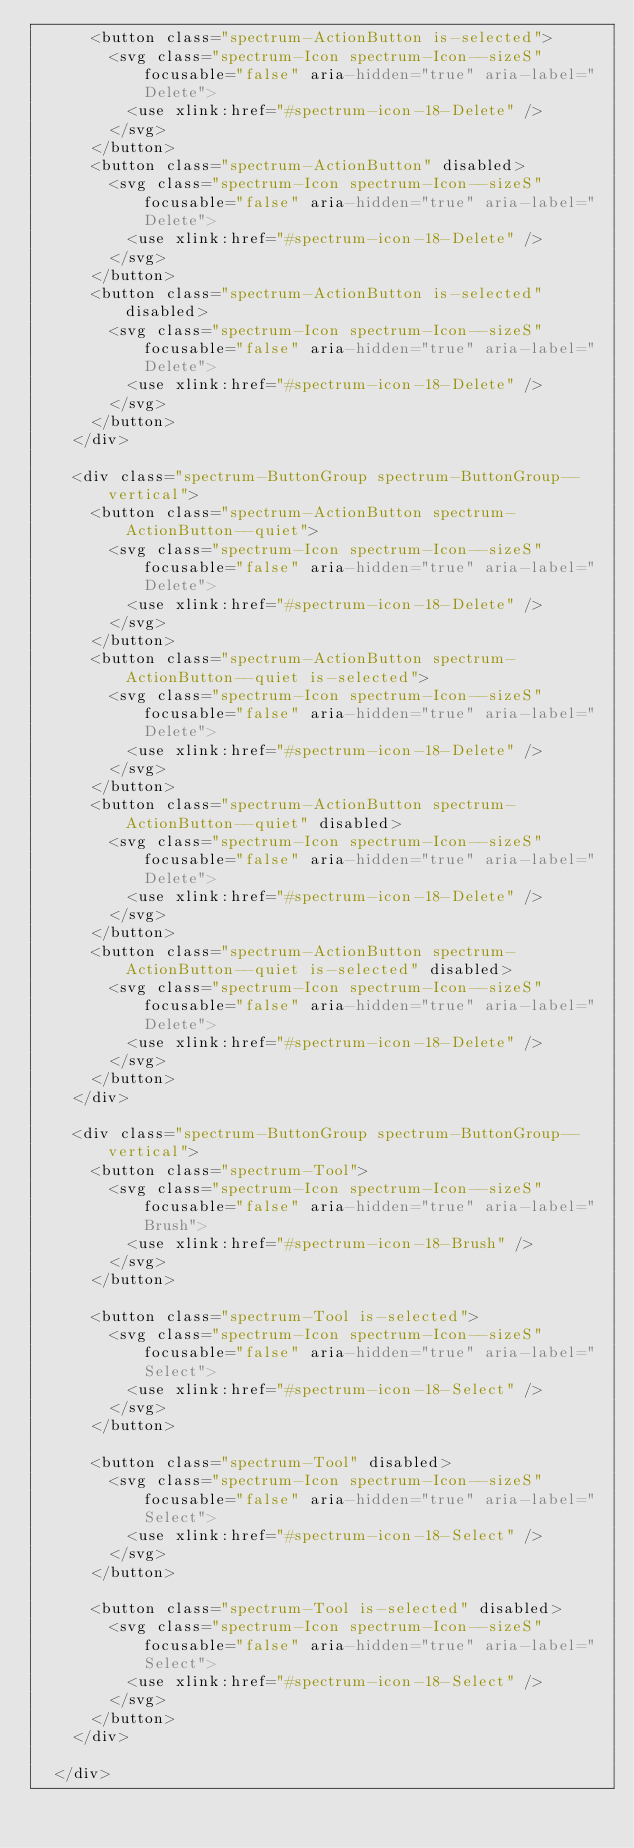<code> <loc_0><loc_0><loc_500><loc_500><_YAML_>      <button class="spectrum-ActionButton is-selected">
        <svg class="spectrum-Icon spectrum-Icon--sizeS" focusable="false" aria-hidden="true" aria-label="Delete">
          <use xlink:href="#spectrum-icon-18-Delete" />
        </svg>
      </button>
      <button class="spectrum-ActionButton" disabled>
        <svg class="spectrum-Icon spectrum-Icon--sizeS" focusable="false" aria-hidden="true" aria-label="Delete">
          <use xlink:href="#spectrum-icon-18-Delete" />
        </svg>
      </button>
      <button class="spectrum-ActionButton is-selected" disabled>
        <svg class="spectrum-Icon spectrum-Icon--sizeS" focusable="false" aria-hidden="true" aria-label="Delete">
          <use xlink:href="#spectrum-icon-18-Delete" />
        </svg>
      </button>
    </div>

    <div class="spectrum-ButtonGroup spectrum-ButtonGroup--vertical">
      <button class="spectrum-ActionButton spectrum-ActionButton--quiet">
        <svg class="spectrum-Icon spectrum-Icon--sizeS" focusable="false" aria-hidden="true" aria-label="Delete">
          <use xlink:href="#spectrum-icon-18-Delete" />
        </svg>
      </button>
      <button class="spectrum-ActionButton spectrum-ActionButton--quiet is-selected">
        <svg class="spectrum-Icon spectrum-Icon--sizeS" focusable="false" aria-hidden="true" aria-label="Delete">
          <use xlink:href="#spectrum-icon-18-Delete" />
        </svg>
      </button>
      <button class="spectrum-ActionButton spectrum-ActionButton--quiet" disabled>
        <svg class="spectrum-Icon spectrum-Icon--sizeS" focusable="false" aria-hidden="true" aria-label="Delete">
          <use xlink:href="#spectrum-icon-18-Delete" />
        </svg>
      </button>
      <button class="spectrum-ActionButton spectrum-ActionButton--quiet is-selected" disabled>
        <svg class="spectrum-Icon spectrum-Icon--sizeS" focusable="false" aria-hidden="true" aria-label="Delete">
          <use xlink:href="#spectrum-icon-18-Delete" />
        </svg>
      </button>
    </div>

    <div class="spectrum-ButtonGroup spectrum-ButtonGroup--vertical">
      <button class="spectrum-Tool">
        <svg class="spectrum-Icon spectrum-Icon--sizeS" focusable="false" aria-hidden="true" aria-label="Brush">
          <use xlink:href="#spectrum-icon-18-Brush" />
        </svg>
      </button>

      <button class="spectrum-Tool is-selected">
        <svg class="spectrum-Icon spectrum-Icon--sizeS" focusable="false" aria-hidden="true" aria-label="Select">
          <use xlink:href="#spectrum-icon-18-Select" />
        </svg>
      </button>

      <button class="spectrum-Tool" disabled>
        <svg class="spectrum-Icon spectrum-Icon--sizeS" focusable="false" aria-hidden="true" aria-label="Select">
          <use xlink:href="#spectrum-icon-18-Select" />
        </svg>
      </button>

      <button class="spectrum-Tool is-selected" disabled>
        <svg class="spectrum-Icon spectrum-Icon--sizeS" focusable="false" aria-hidden="true" aria-label="Select">
          <use xlink:href="#spectrum-icon-18-Select" />
        </svg>
      </button>
    </div>

  </div>
</code> 